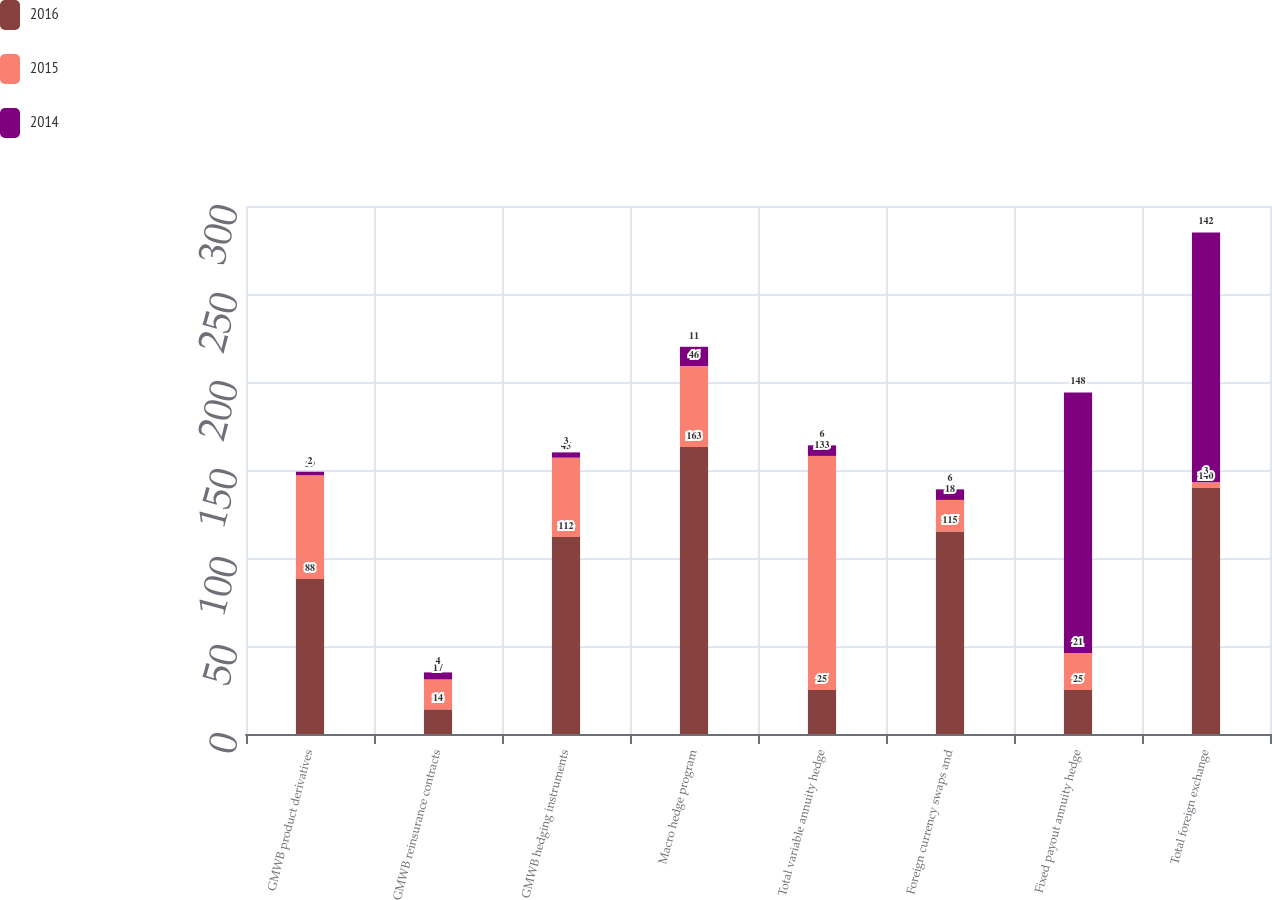Convert chart to OTSL. <chart><loc_0><loc_0><loc_500><loc_500><stacked_bar_chart><ecel><fcel>GMWB product derivatives<fcel>GMWB reinsurance contracts<fcel>GMWB hedging instruments<fcel>Macro hedge program<fcel>Total variable annuity hedge<fcel>Foreign currency swaps and<fcel>Fixed payout annuity hedge<fcel>Total foreign exchange<nl><fcel>2016<fcel>88<fcel>14<fcel>112<fcel>163<fcel>25<fcel>115<fcel>25<fcel>140<nl><fcel>2015<fcel>59<fcel>17<fcel>45<fcel>46<fcel>133<fcel>18<fcel>21<fcel>3<nl><fcel>2014<fcel>2<fcel>4<fcel>3<fcel>11<fcel>6<fcel>6<fcel>148<fcel>142<nl></chart> 